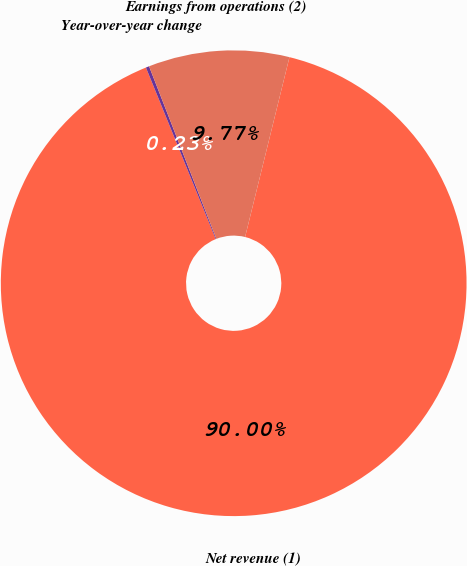<chart> <loc_0><loc_0><loc_500><loc_500><pie_chart><fcel>Net revenue (1)<fcel>Year-over-year change<fcel>Earnings from operations (2)<nl><fcel>90.01%<fcel>0.23%<fcel>9.77%<nl></chart> 